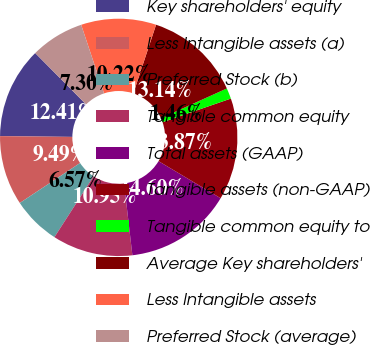<chart> <loc_0><loc_0><loc_500><loc_500><pie_chart><fcel>Key shareholders' equity<fcel>Less Intangible assets (a)<fcel>Preferred Stock (b)<fcel>Tangible common equity<fcel>Total assets (GAAP)<fcel>Tangible assets (non-GAAP)<fcel>Tangible common equity to<fcel>Average Key shareholders'<fcel>Less Intangible assets<fcel>Preferred Stock (average)<nl><fcel>12.41%<fcel>9.49%<fcel>6.57%<fcel>10.95%<fcel>14.6%<fcel>13.87%<fcel>1.46%<fcel>13.14%<fcel>10.22%<fcel>7.3%<nl></chart> 